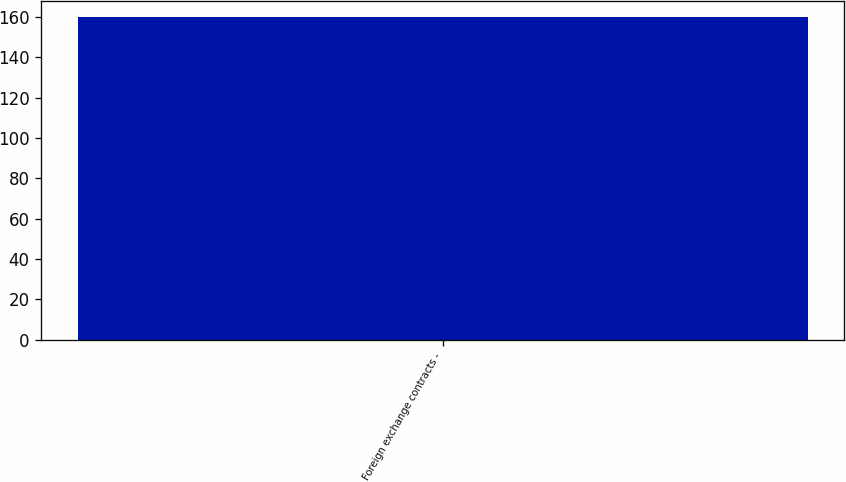Convert chart to OTSL. <chart><loc_0><loc_0><loc_500><loc_500><bar_chart><fcel>Foreign exchange contracts -<nl><fcel>160<nl></chart> 